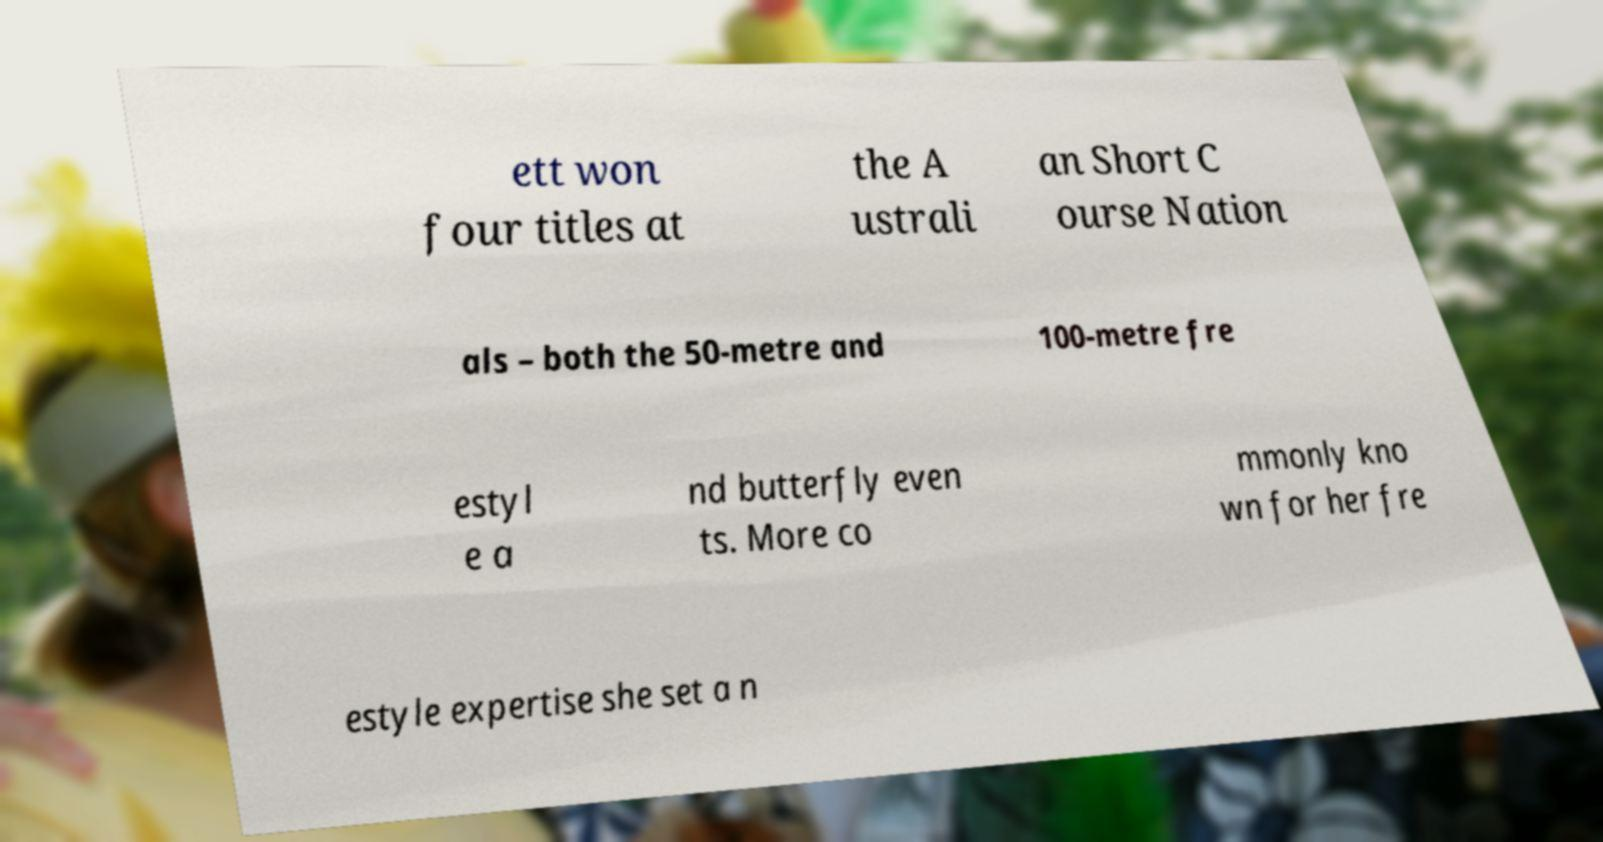Can you accurately transcribe the text from the provided image for me? ett won four titles at the A ustrali an Short C ourse Nation als – both the 50-metre and 100-metre fre estyl e a nd butterfly even ts. More co mmonly kno wn for her fre estyle expertise she set a n 